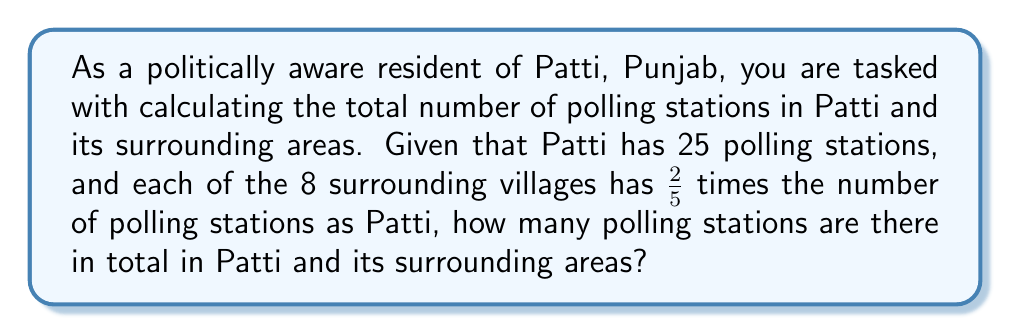Give your solution to this math problem. To solve this problem, let's break it down into steps:

1. Number of polling stations in Patti:
   $P_{Patti} = 25$

2. Number of polling stations in each surrounding village:
   $P_{village} = \frac{2}{5} \times P_{Patti} = \frac{2}{5} \times 25 = 10$

3. Number of surrounding villages:
   $N_{villages} = 8$

4. Total number of polling stations in surrounding villages:
   $P_{surrounding} = P_{village} \times N_{villages} = 10 \times 8 = 80$

5. Total number of polling stations in Patti and surrounding areas:
   $$P_{total} = P_{Patti} + P_{surrounding} = 25 + 80 = 105$$

Therefore, the total number of polling stations in Patti and its surrounding areas is 105.
Answer: 105 polling stations 